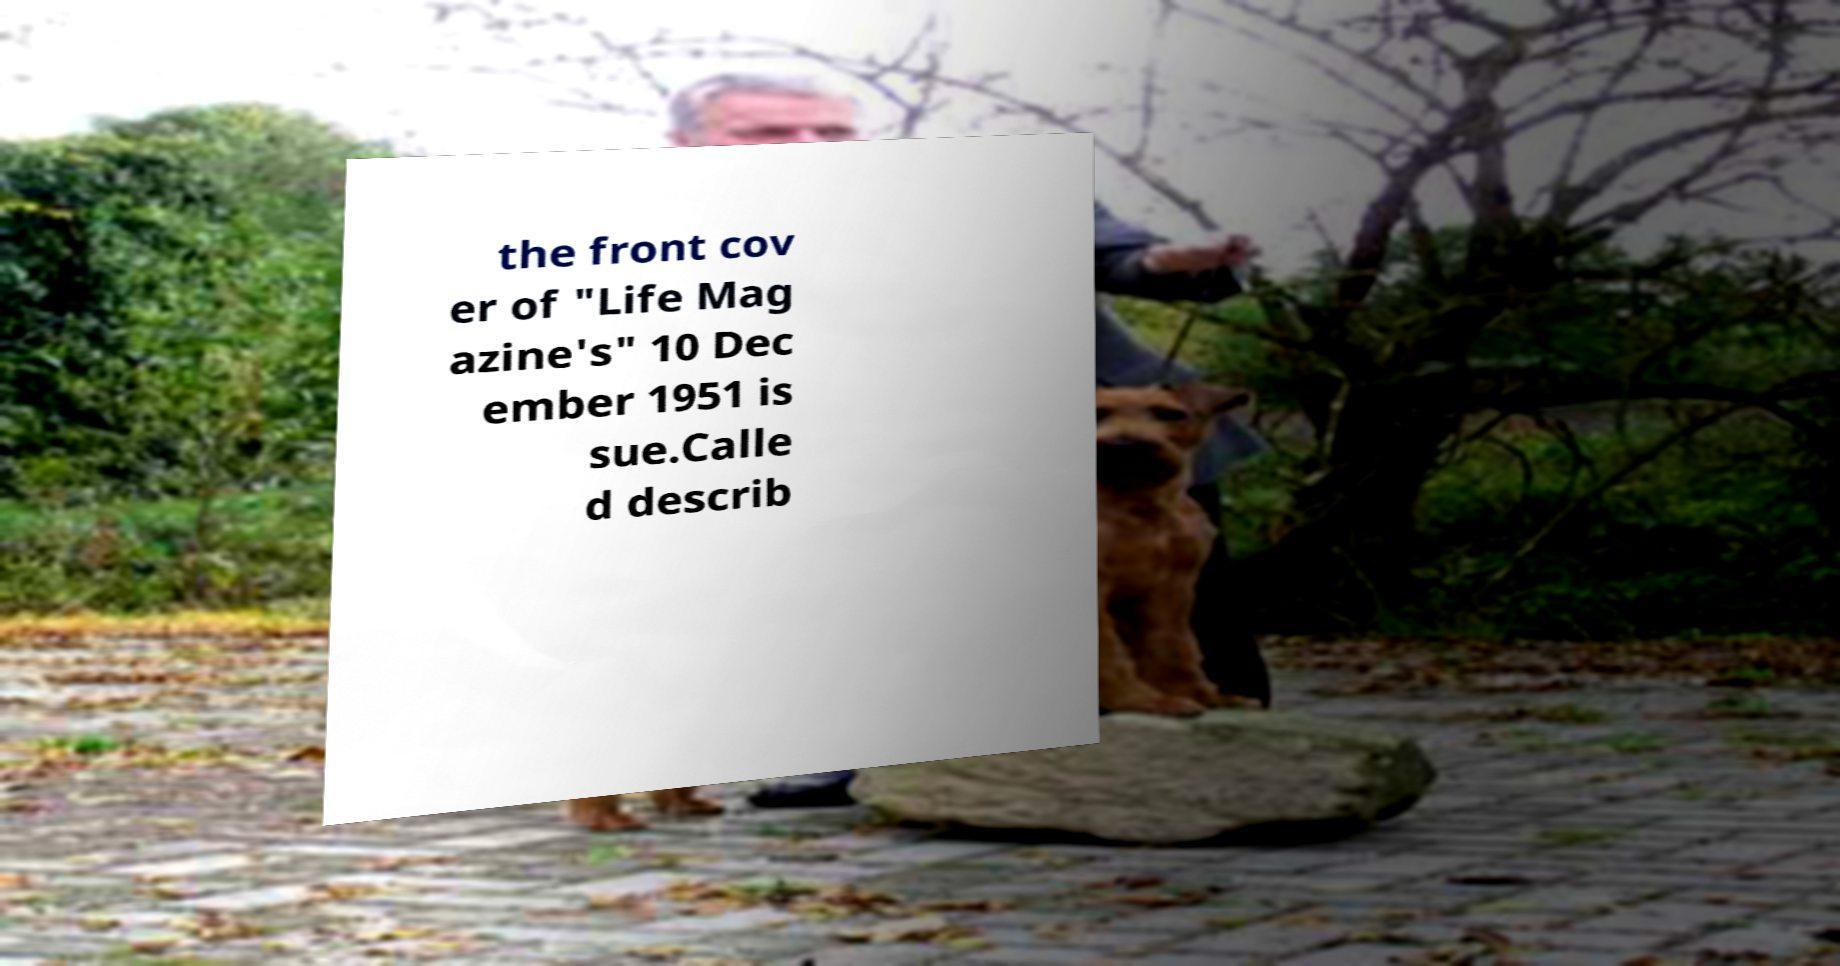What messages or text are displayed in this image? I need them in a readable, typed format. the front cov er of "Life Mag azine's" 10 Dec ember 1951 is sue.Calle d describ 